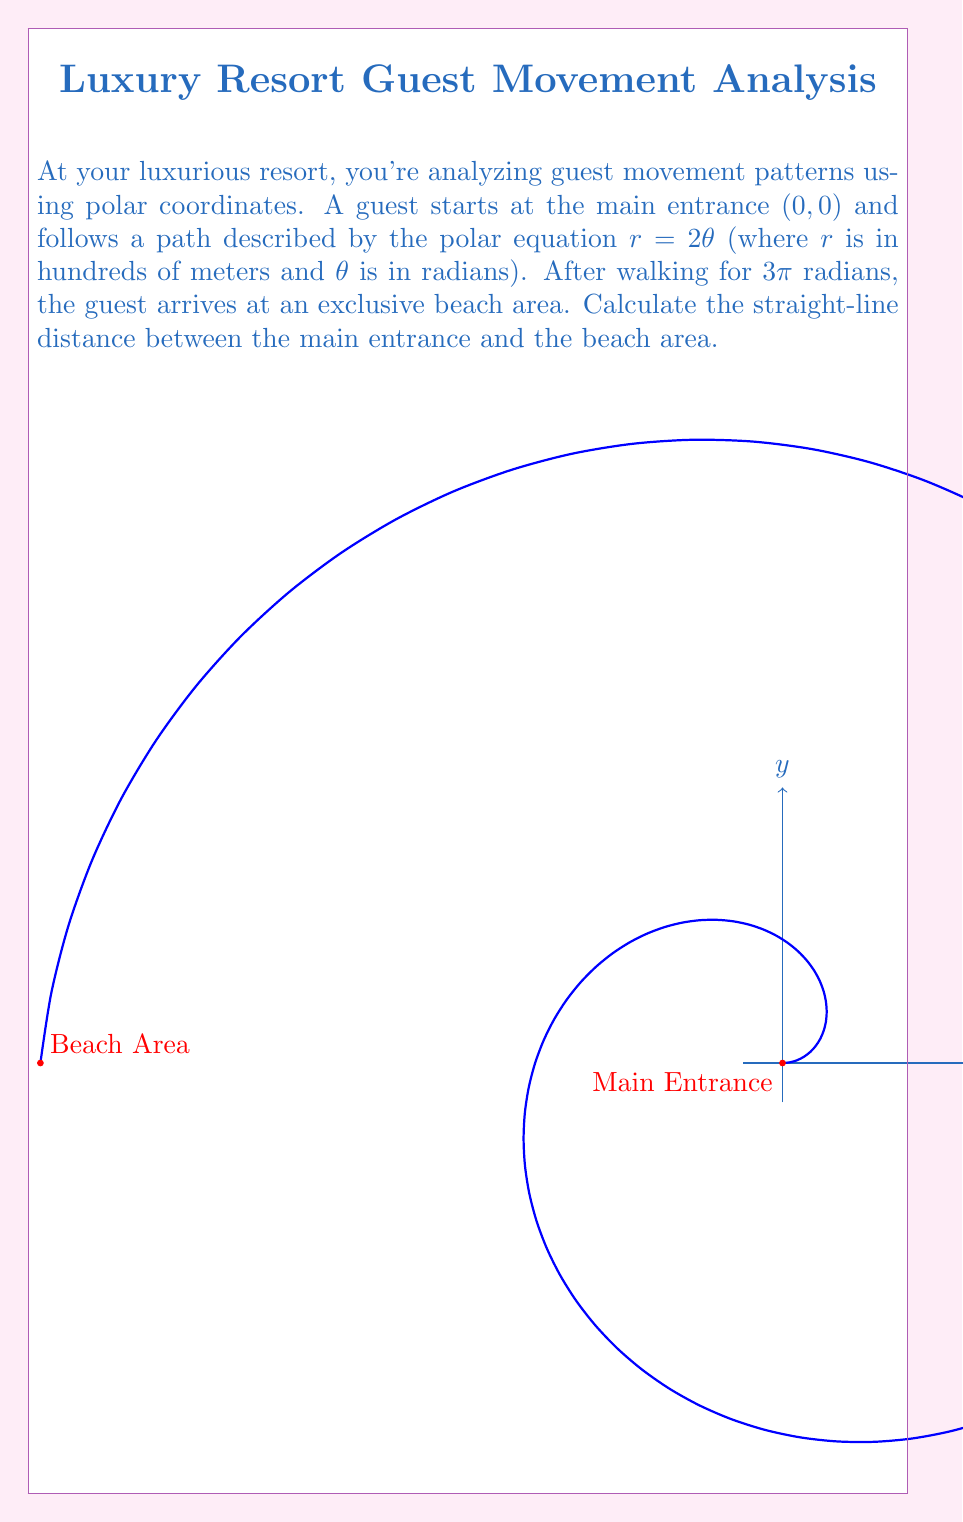Show me your answer to this math problem. Let's approach this step-by-step:

1) The polar equation of the path is $r = 2\theta$. After walking for 3π radians, we need to find the final coordinates of the guest.

2) At $\theta = 3\pi$, the radial distance $r$ is:
   $r = 2(3\pi) = 6\pi$ hundreds of meters

3) To find the Cartesian coordinates of this point, we use the conversion formulas:
   $x = r \cos(\theta)$
   $y = r \sin(\theta)$

4) Substituting our values:
   $x = 6\pi \cos(3\pi) = 6\pi(-1) = -6\pi$
   $y = 6\pi \sin(3\pi) = 6\pi(0) = 0$

5) So, the beach area is at the point $(-6\pi, 0)$ in Cartesian coordinates.

6) The straight-line distance from (0,0) to $(-6\pi, 0)$ can be calculated using the distance formula:
   $d = \sqrt{(x_2-x_1)^2 + (y_2-y_1)^2}$

7) Plugging in our values:
   $d = \sqrt{(-6\pi-0)^2 + (0-0)^2} = \sqrt{36\pi^2} = 6\pi$

8) Therefore, the straight-line distance is $6\pi$ hundreds of meters, or $600\pi$ meters.
Answer: $600\pi$ meters 